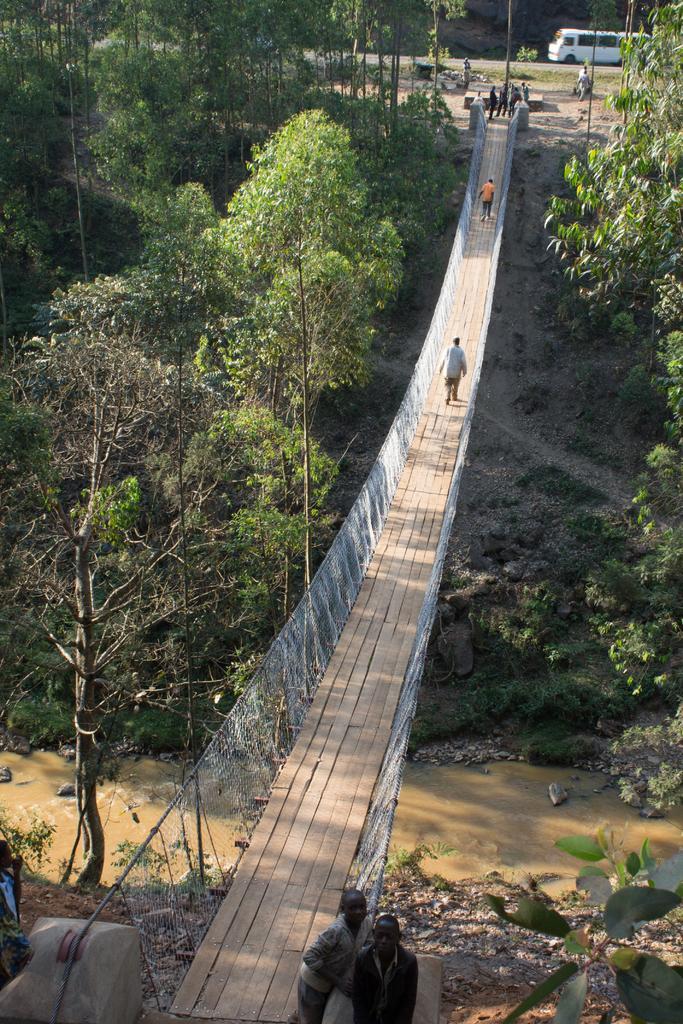Can you describe this image briefly? In the image there is a bridge across the river and there are few people on the either side of the bridge, around that there are trees and in the background there is a vehicle. 